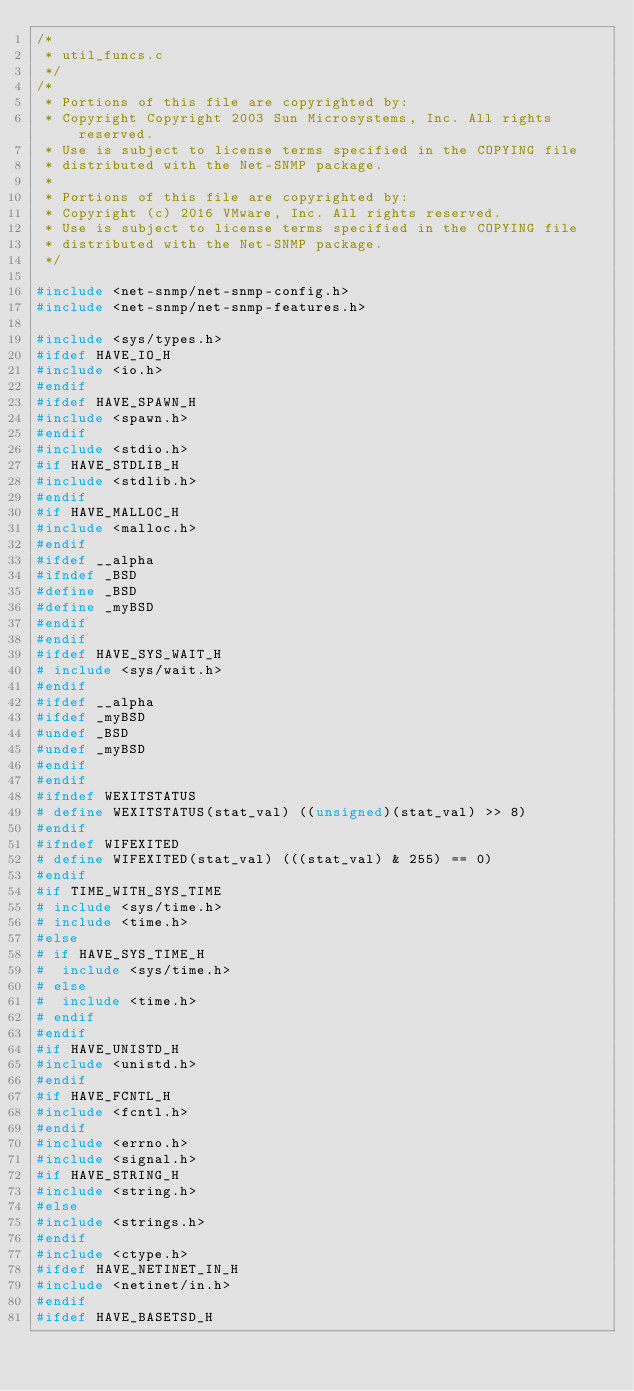Convert code to text. <code><loc_0><loc_0><loc_500><loc_500><_C_>/*
 * util_funcs.c
 */
/*
 * Portions of this file are copyrighted by:
 * Copyright Copyright 2003 Sun Microsystems, Inc. All rights reserved.
 * Use is subject to license terms specified in the COPYING file
 * distributed with the Net-SNMP package.
 *
 * Portions of this file are copyrighted by:
 * Copyright (c) 2016 VMware, Inc. All rights reserved.
 * Use is subject to license terms specified in the COPYING file
 * distributed with the Net-SNMP package.
 */

#include <net-snmp/net-snmp-config.h>
#include <net-snmp/net-snmp-features.h>

#include <sys/types.h>
#ifdef HAVE_IO_H
#include <io.h>
#endif
#ifdef HAVE_SPAWN_H
#include <spawn.h>
#endif
#include <stdio.h>
#if HAVE_STDLIB_H
#include <stdlib.h>
#endif
#if HAVE_MALLOC_H
#include <malloc.h>
#endif
#ifdef __alpha
#ifndef _BSD
#define _BSD
#define _myBSD
#endif
#endif
#ifdef HAVE_SYS_WAIT_H
# include <sys/wait.h>
#endif
#ifdef __alpha
#ifdef _myBSD
#undef _BSD
#undef _myBSD
#endif
#endif
#ifndef WEXITSTATUS
# define WEXITSTATUS(stat_val) ((unsigned)(stat_val) >> 8)
#endif
#ifndef WIFEXITED
# define WIFEXITED(stat_val) (((stat_val) & 255) == 0)
#endif
#if TIME_WITH_SYS_TIME
# include <sys/time.h>
# include <time.h>
#else
# if HAVE_SYS_TIME_H
#  include <sys/time.h>
# else
#  include <time.h>
# endif
#endif
#if HAVE_UNISTD_H
#include <unistd.h>
#endif
#if HAVE_FCNTL_H
#include <fcntl.h>
#endif
#include <errno.h>
#include <signal.h>
#if HAVE_STRING_H
#include <string.h>
#else
#include <strings.h>
#endif
#include <ctype.h>
#ifdef HAVE_NETINET_IN_H
#include <netinet/in.h>
#endif
#ifdef HAVE_BASETSD_H</code> 